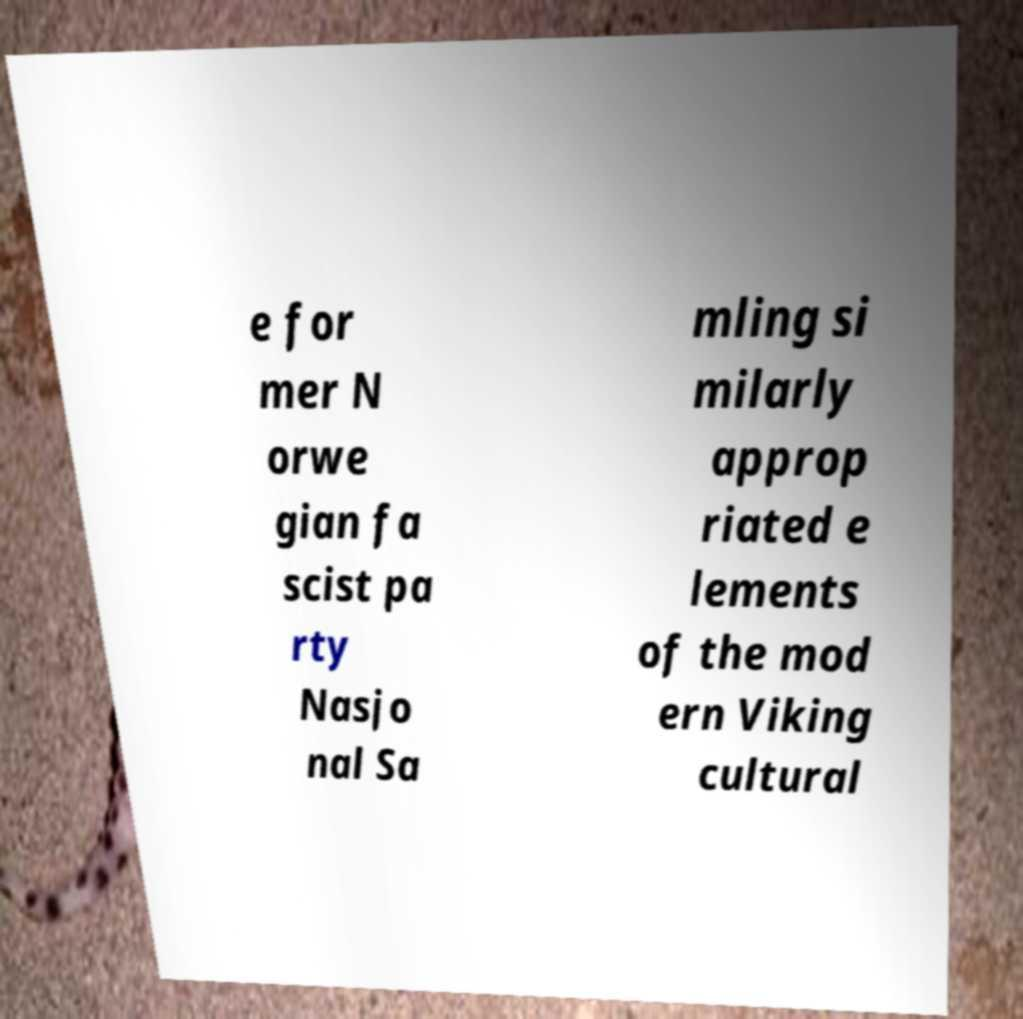Can you read and provide the text displayed in the image?This photo seems to have some interesting text. Can you extract and type it out for me? e for mer N orwe gian fa scist pa rty Nasjo nal Sa mling si milarly approp riated e lements of the mod ern Viking cultural 